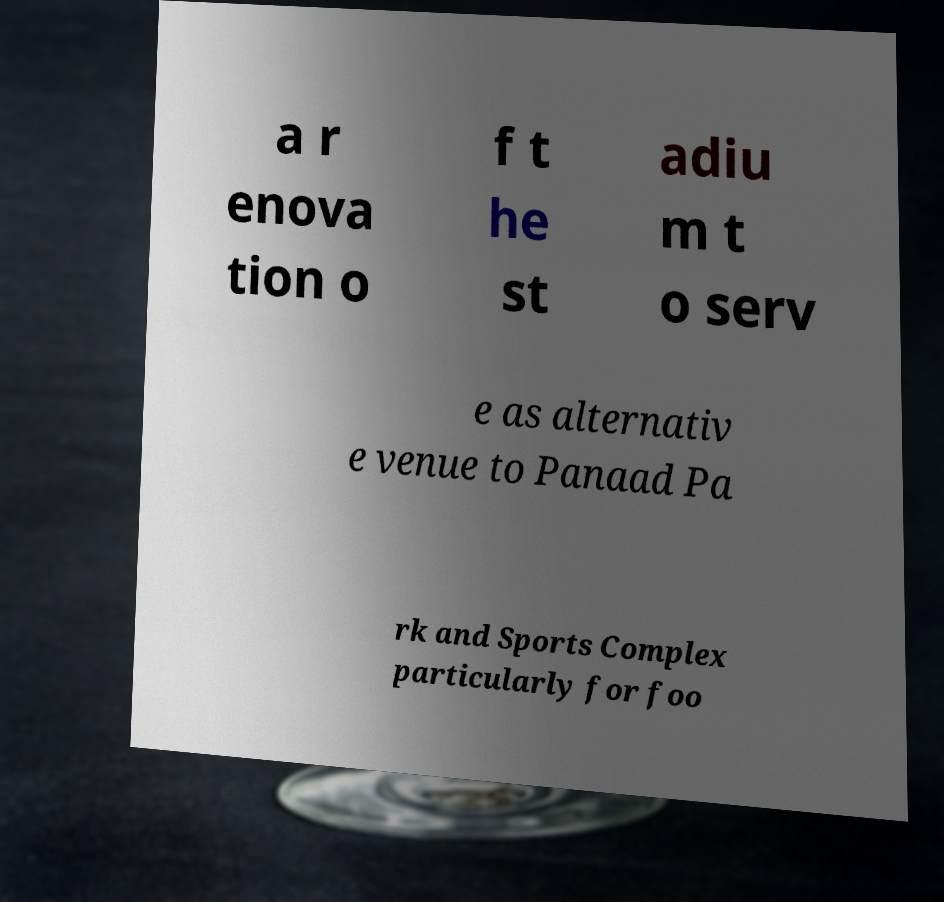For documentation purposes, I need the text within this image transcribed. Could you provide that? a r enova tion o f t he st adiu m t o serv e as alternativ e venue to Panaad Pa rk and Sports Complex particularly for foo 